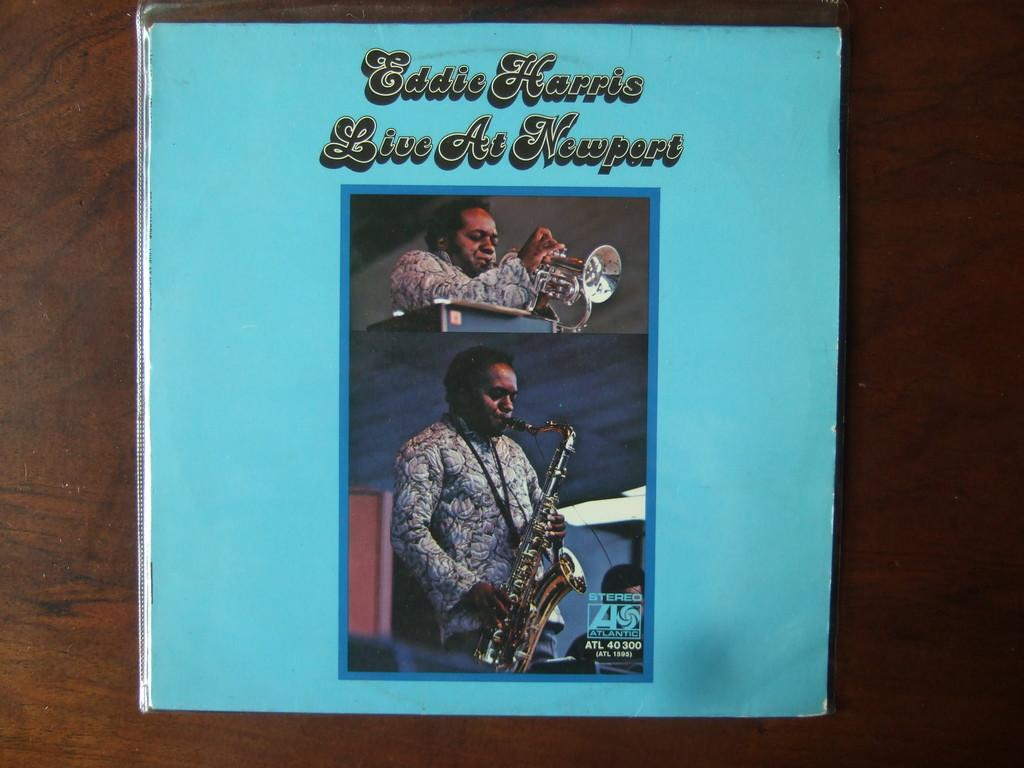<image>
Provide a brief description of the given image. The cover of the album Eddie Harris Live at Newport shows him playing a saxophone. 